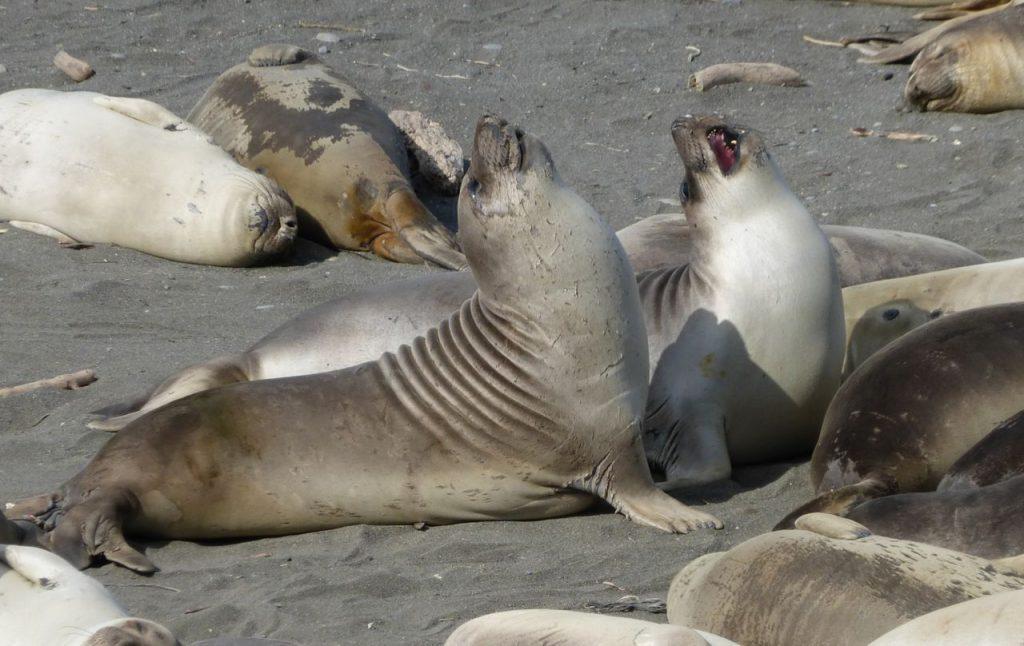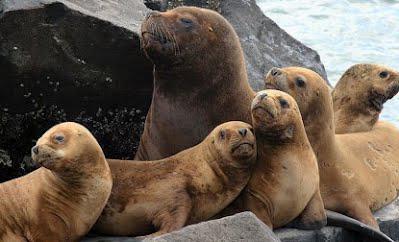The first image is the image on the left, the second image is the image on the right. Evaluate the accuracy of this statement regarding the images: "Right image shows one large mail seal and several small females.". Is it true? Answer yes or no. Yes. The first image is the image on the left, the second image is the image on the right. Assess this claim about the two images: "There is water in the image on the left.". Correct or not? Answer yes or no. No. 